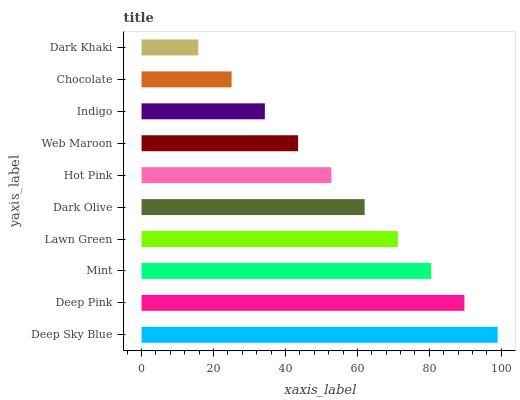Is Dark Khaki the minimum?
Answer yes or no. Yes. Is Deep Sky Blue the maximum?
Answer yes or no. Yes. Is Deep Pink the minimum?
Answer yes or no. No. Is Deep Pink the maximum?
Answer yes or no. No. Is Deep Sky Blue greater than Deep Pink?
Answer yes or no. Yes. Is Deep Pink less than Deep Sky Blue?
Answer yes or no. Yes. Is Deep Pink greater than Deep Sky Blue?
Answer yes or no. No. Is Deep Sky Blue less than Deep Pink?
Answer yes or no. No. Is Dark Olive the high median?
Answer yes or no. Yes. Is Hot Pink the low median?
Answer yes or no. Yes. Is Deep Pink the high median?
Answer yes or no. No. Is Mint the low median?
Answer yes or no. No. 